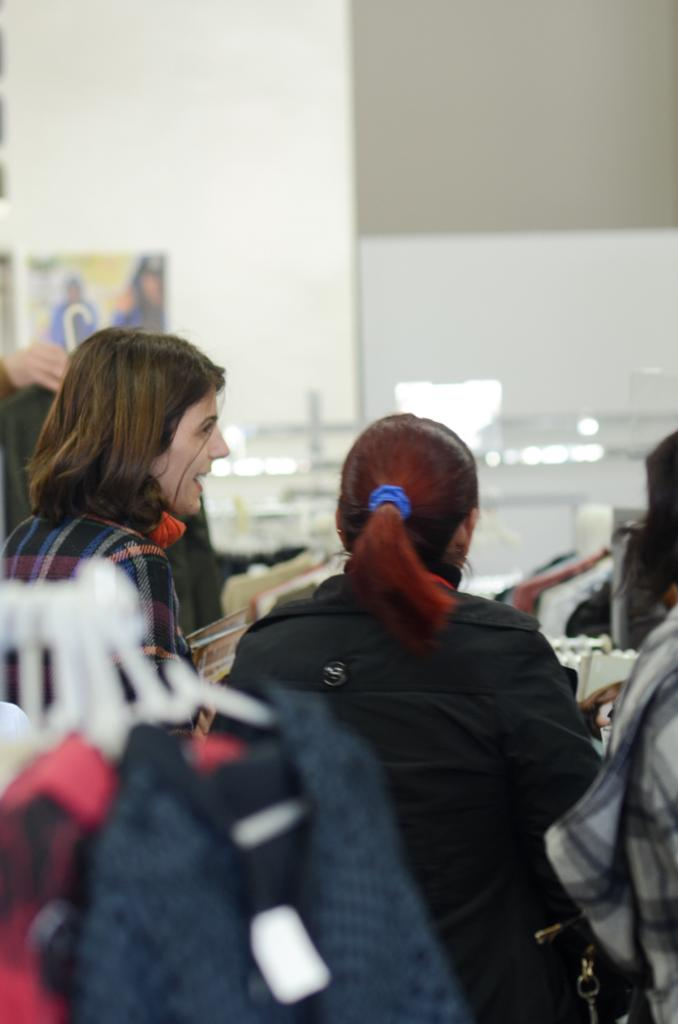Who or what can be seen in the image? There are people in the image. What are the people wearing or holding in the image? There are dresses in the image. What is on the wall in the image? There is a poster on the wall in the image. Where is the chicken located in the image? There is no chicken present in the image. What type of ball is being used by the people in the image? There is no ball present in the image. 